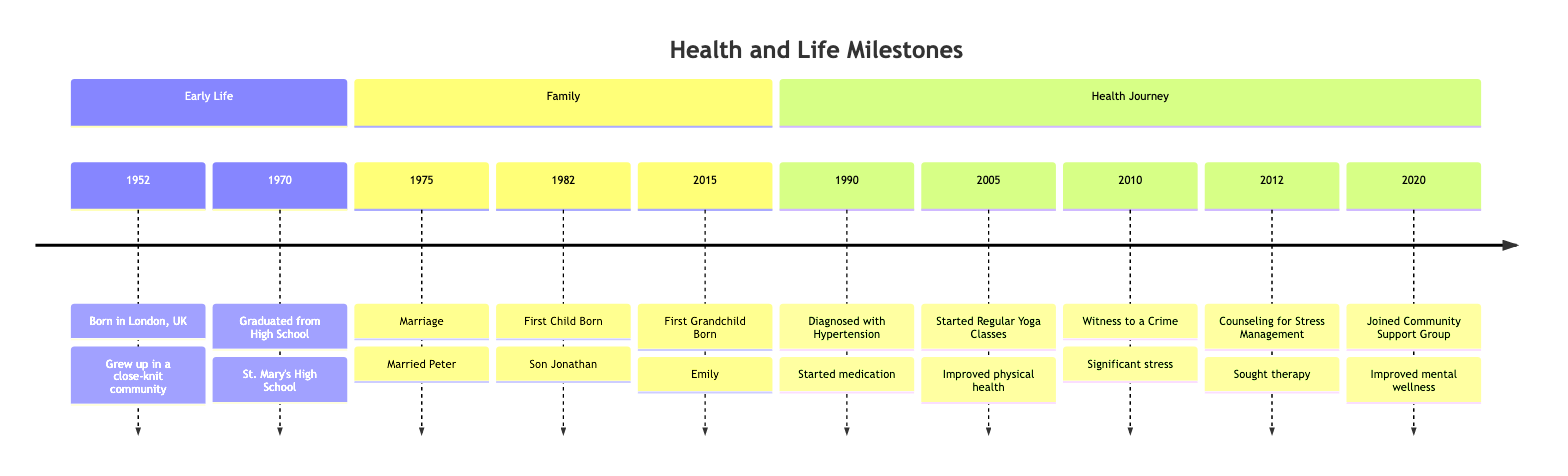What year was the first grandchild born? The timeline lists the years along with significant events. The milestone for the first grandchild born is 2015.
Answer: 2015 What event occurred in 1990? In the year 1990, the timeline states that the individual was diagnosed with hypertension.
Answer: Diagnosed with Hypertension How many events are listed in the "Family" section? The "Family" section contains three events: Marriage in 1975, First Child Born in 1982, and First Grandchild Born in 2015.
Answer: 3 What significant health journey event occurred after 2010? According to the timeline, after the event of being a witness to a crime in 2010, the next event listed is counseling for stress management in 2012.
Answer: Counseling for Stress Management Which year marks the start of regular yoga classes? The timeline specifies that regular yoga classes began in 2005.
Answer: 2005 What transition in well-being occurred in 2020? The 2020 milestone indicates participation in a community support group aimed at improving mental wellness and social connectedness.
Answer: Community Support Group What year was the son born? The timeline indicates that the first child, a son named Jonathan, was born in 1982.
Answer: 1982 Which event is listed before the marriage? Reviewing the timeline, the event listed before the marriage in 1975 is the graduation from high school in 1970.
Answer: Graduated from High School What common theme connects the events in the "Health Journey" section? The common theme in the "Health Journey" section is the individual's focus on managing health and emotional well-being through various methods, such as medication, yoga, counseling, and community support.
Answer: Managing health and well-being 